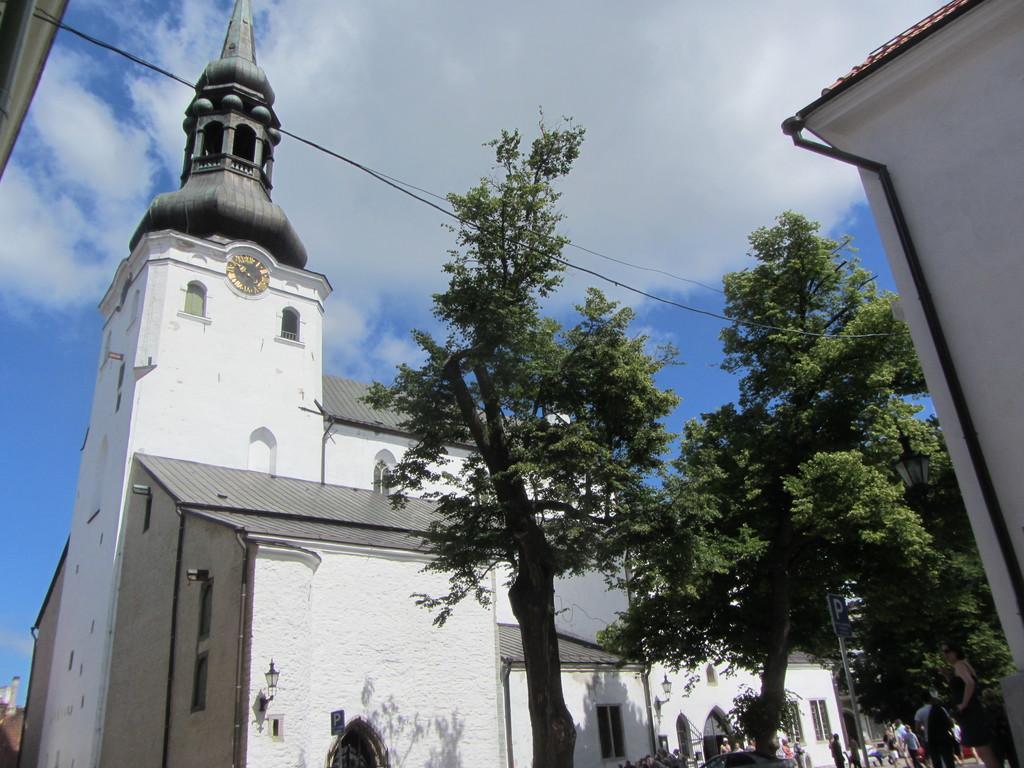How would you summarize this image in a sentence or two? In the image there are trees on the right side and a building on the left side with a clock in the middle and above its sky with clouds. 